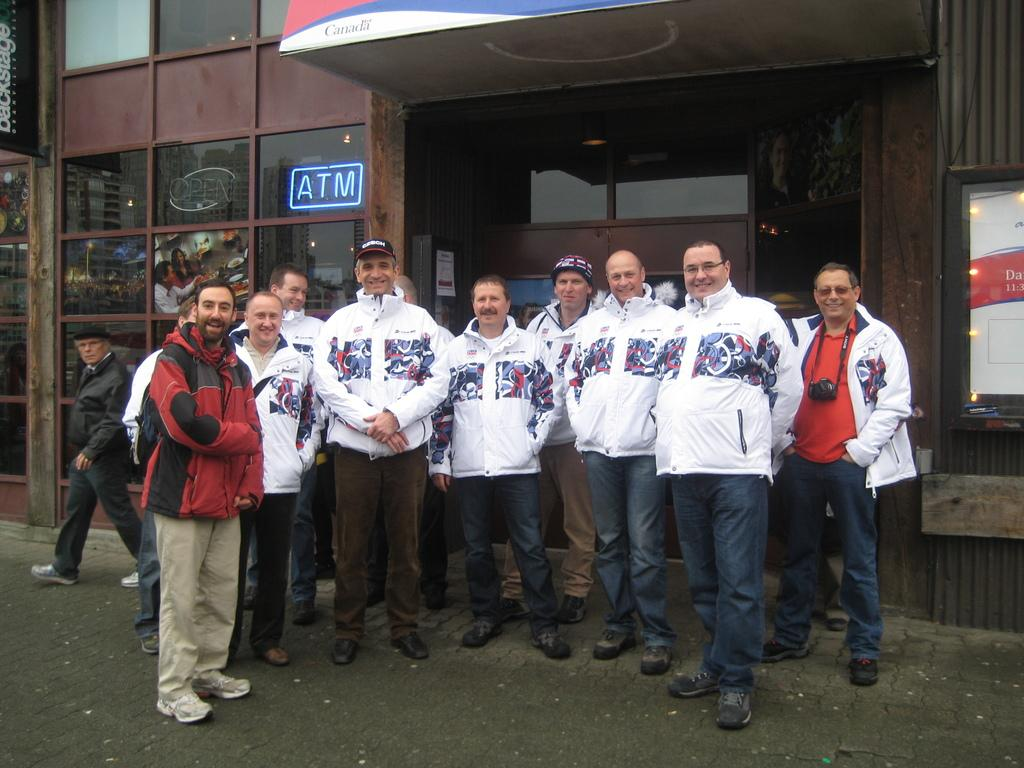<image>
Write a terse but informative summary of the picture. Several men are standing outside of an establishment, with a blue ATM sign, wearing matching jackets. 